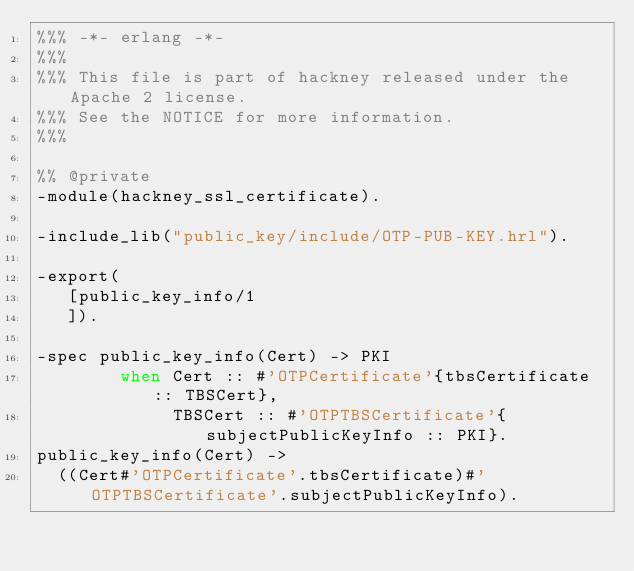<code> <loc_0><loc_0><loc_500><loc_500><_Erlang_>%%% -*- erlang -*-
%%%
%%% This file is part of hackney released under the Apache 2 license.
%%% See the NOTICE for more information.
%%%

%% @private
-module(hackney_ssl_certificate).

-include_lib("public_key/include/OTP-PUB-KEY.hrl").

-export(
   [public_key_info/1
   ]).

-spec public_key_info(Cert) -> PKI
        when Cert :: #'OTPCertificate'{tbsCertificate :: TBSCert},
             TBSCert :: #'OTPTBSCertificate'{subjectPublicKeyInfo :: PKI}.
public_key_info(Cert) ->
  ((Cert#'OTPCertificate'.tbsCertificate)#'OTPTBSCertificate'.subjectPublicKeyInfo).
</code> 